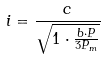<formula> <loc_0><loc_0><loc_500><loc_500>i = \frac { c } { \sqrt { 1 \cdot \frac { b \cdot P } { 3 P _ { m } } } }</formula> 